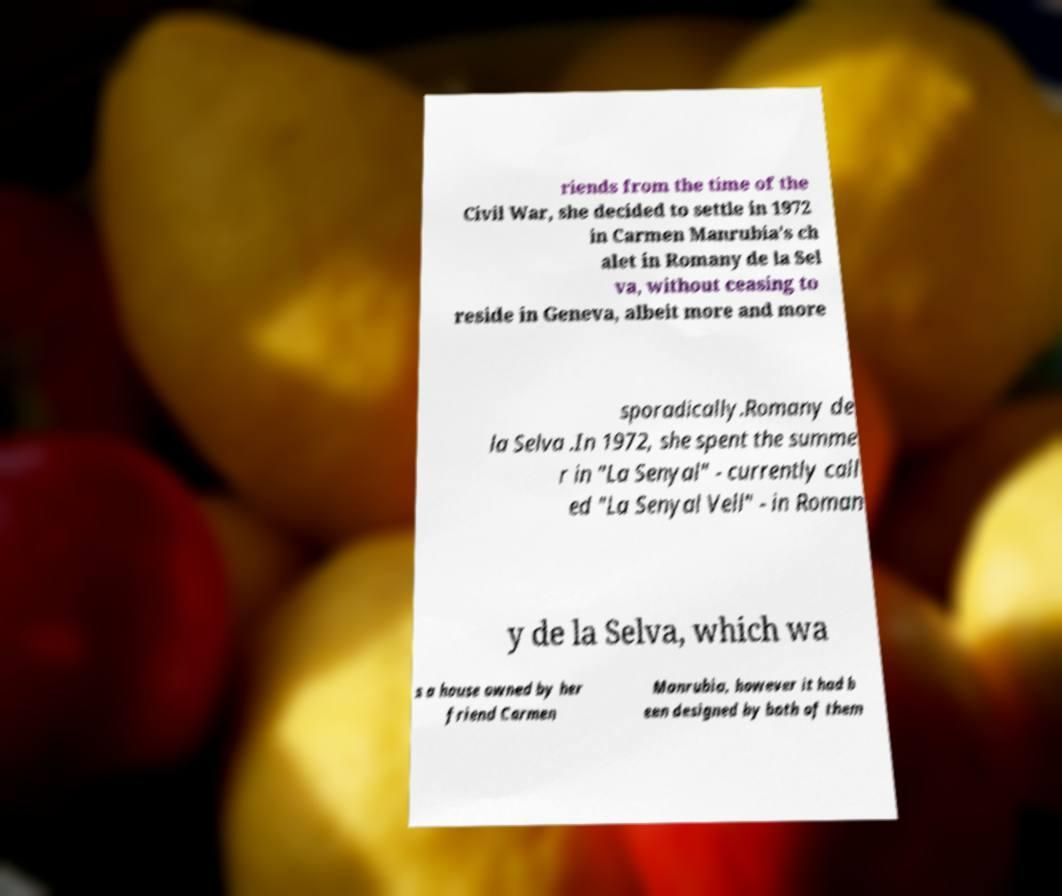What messages or text are displayed in this image? I need them in a readable, typed format. riends from the time of the Civil War, she decided to settle in 1972 in Carmen Manrubia's ch alet in Romany de la Sel va, without ceasing to reside in Geneva, albeit more and more sporadically.Romany de la Selva .In 1972, she spent the summe r in "La Senyal" - currently call ed "La Senyal Vell" - in Roman y de la Selva, which wa s a house owned by her friend Carmen Manrubia, however it had b een designed by both of them 